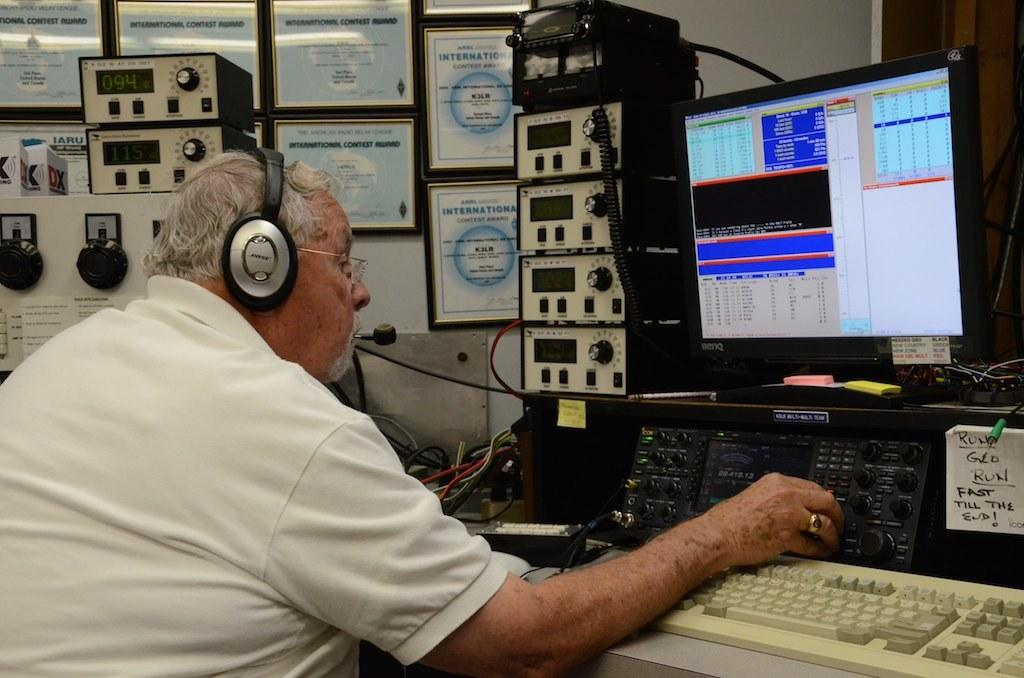Provide a one-sentence caption for the provided image. A man wearing headphones is starring at a monitor and a note saying fast till the end is next to him. 